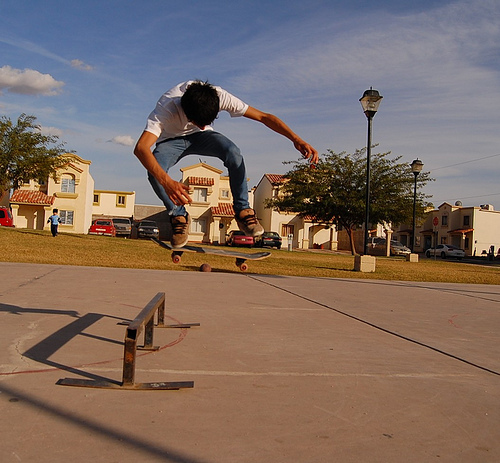What time of day does this image suggest? Based on the length of the shadows and the golden hue in the sky, it seems to be late afternoon or early evening, which is often a cooler and more comfortable time for outdoor physical activities like skateboarding. 